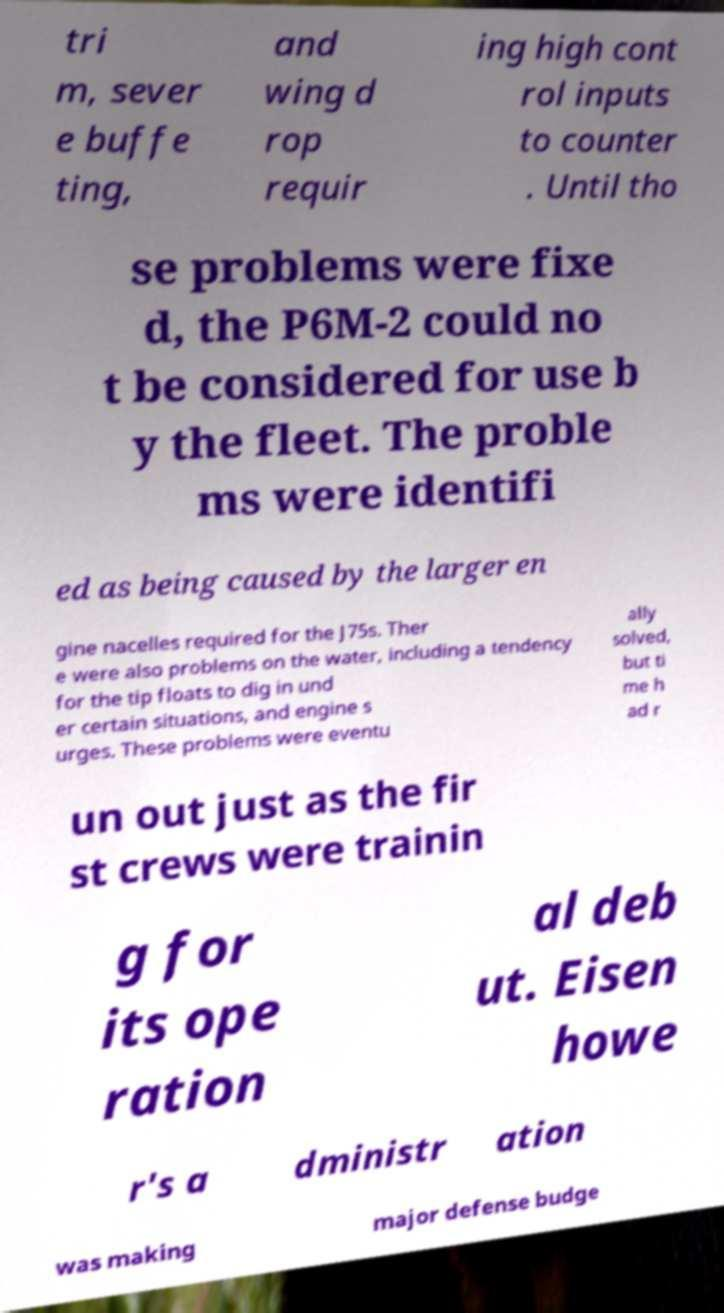For documentation purposes, I need the text within this image transcribed. Could you provide that? tri m, sever e buffe ting, and wing d rop requir ing high cont rol inputs to counter . Until tho se problems were fixe d, the P6M-2 could no t be considered for use b y the fleet. The proble ms were identifi ed as being caused by the larger en gine nacelles required for the J75s. Ther e were also problems on the water, including a tendency for the tip floats to dig in und er certain situations, and engine s urges. These problems were eventu ally solved, but ti me h ad r un out just as the fir st crews were trainin g for its ope ration al deb ut. Eisen howe r's a dministr ation was making major defense budge 